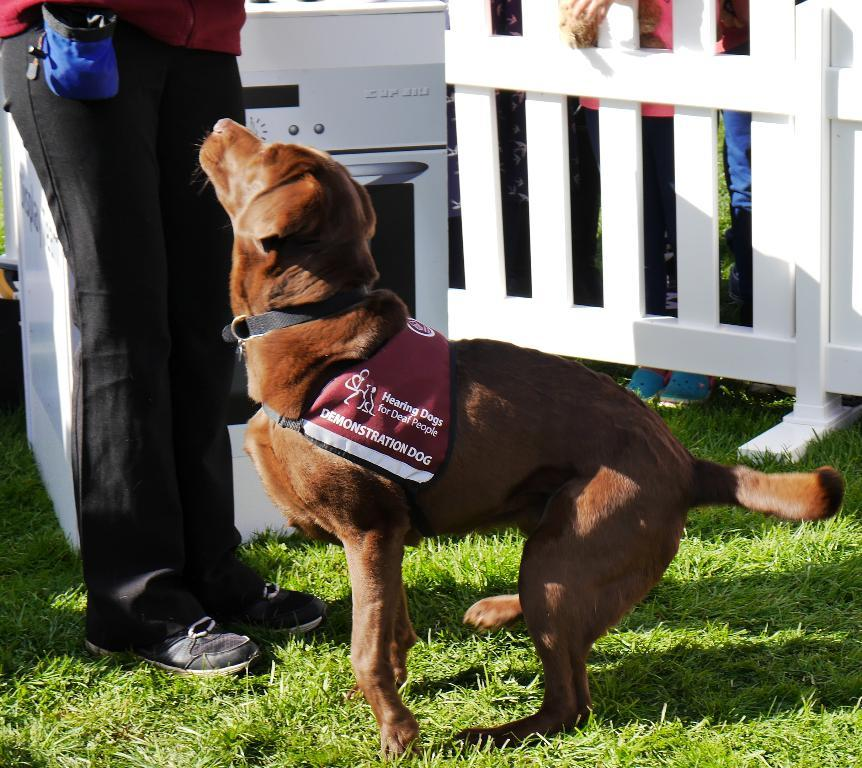What is the main subject of the image? There is a person standing in the image. Can you describe the dog in the image? The dog in the image has a coat and belt. What is located on the grass in the image? There is an object on the grass in the image. What type of barrier is visible in the image? There is a fence in the image. Are there any other people visible in the image? Yes, there are people standing in the background of the image. What type of suit is the father wearing in the image? There is no father present in the image, and no one is wearing a suit. How many spiders can be seen crawling on the fence in the image? There are no spiders visible in the image. 